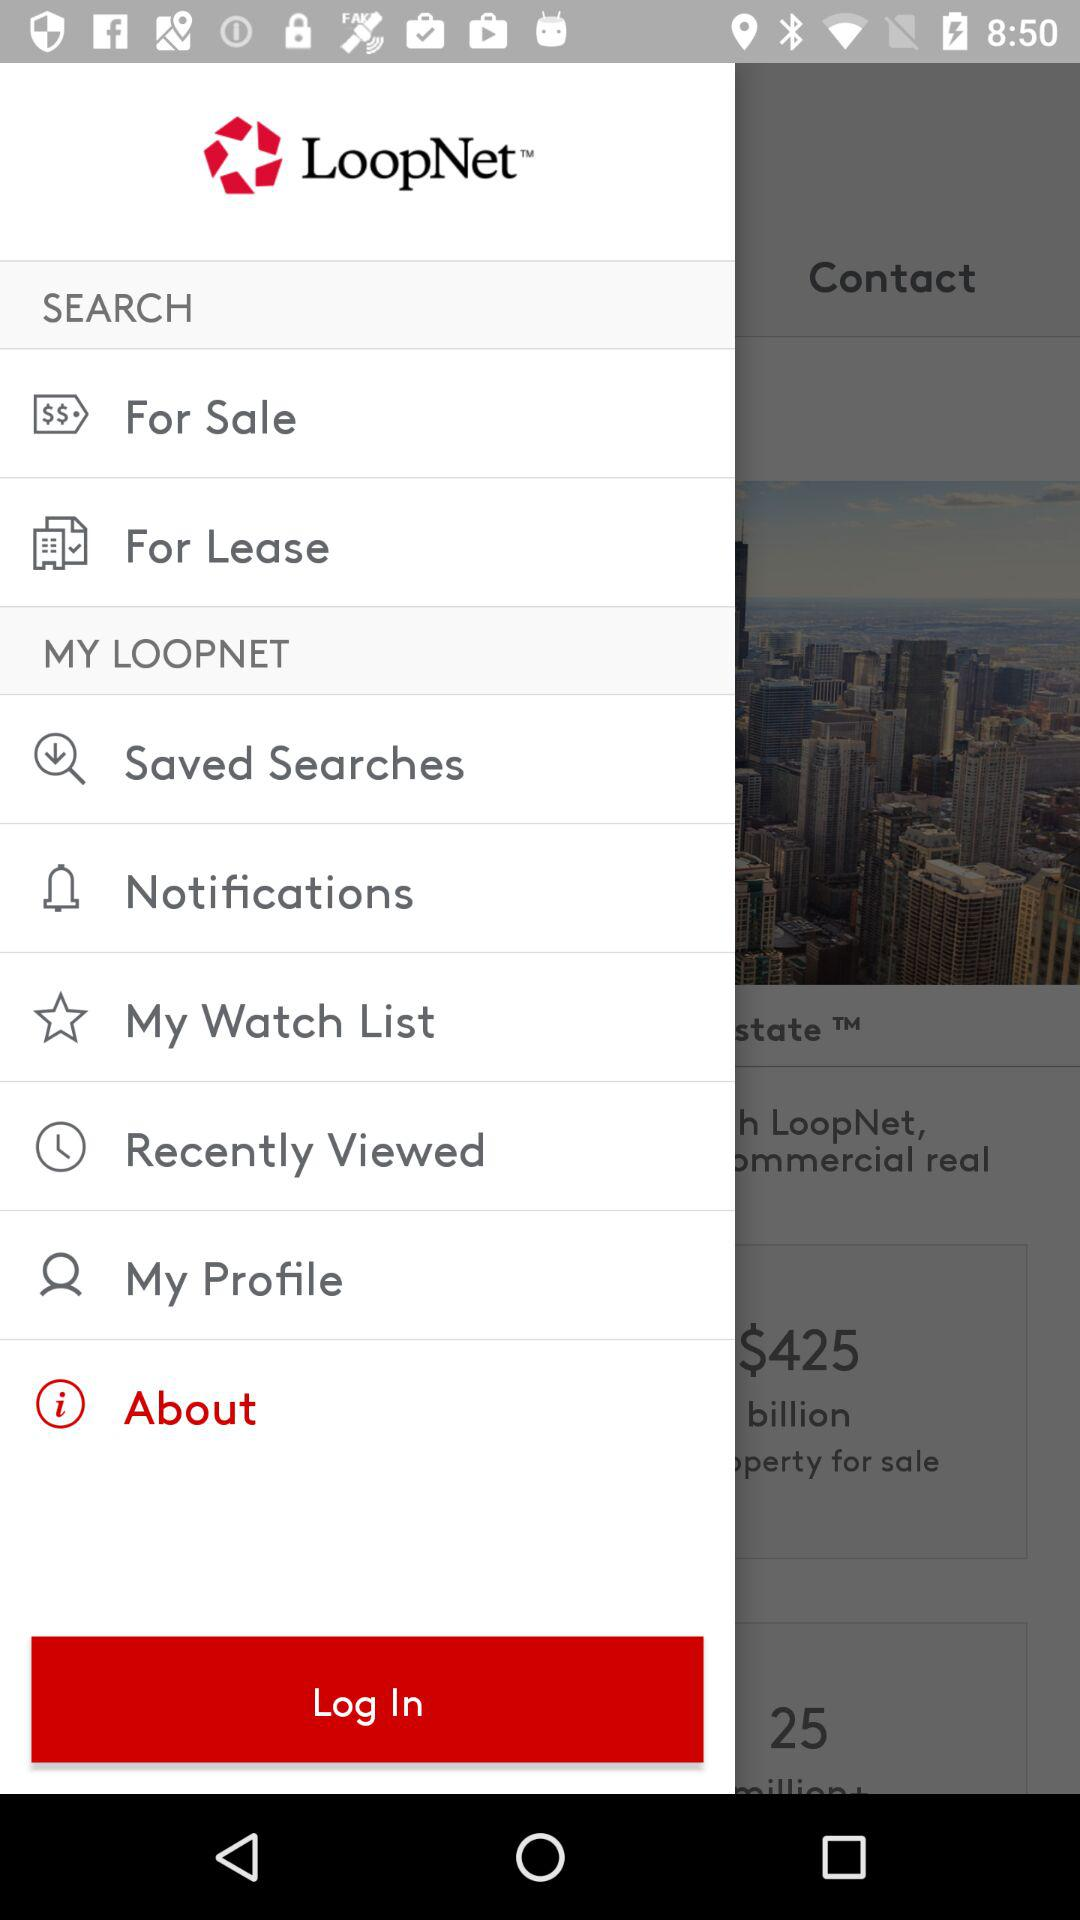Where are the properties that are for sale located?
When the provided information is insufficient, respond with <no answer>. <no answer> 